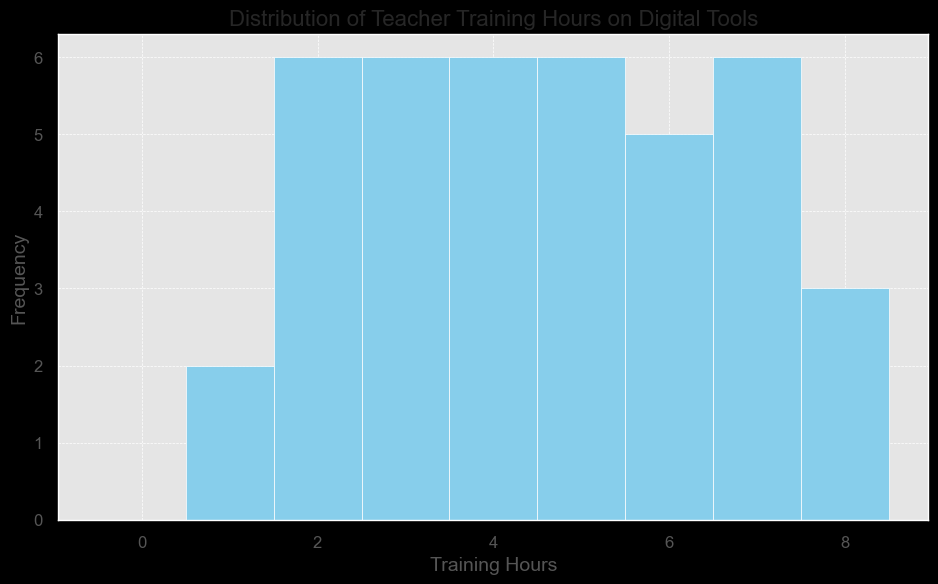What is the most common number of training hours among teachers? The most common number of training hours can be identified by the tallest bar on the histogram. In this case, the tallest bar corresponds to the training hours that occur most frequently.
Answer: 5 How many teachers received exactly 3 hours of training? The number of teachers who received exactly 3 hours of training can be determined by the height of the bar at 3 hours on the x-axis. Count the frequency indicated by this bar.
Answer: 6 What is the range of training hours observed in the data? The range is the difference between the maximum and minimum values of training hours. From the histogram, the lowest value is 1 and the highest is 8. Therefore, the range is 8 - 1.
Answer: 7 Which interval of training hours has the second highest frequency? To find the second highest frequency, look for the second tallest bar in the histogram. The interval it represents is the answer.
Answer: 4 How many teachers received more than 5 hours of training? Count the number of bars corresponding to training hours greater than 5 and sum their frequencies. Bars for 6, 7, and 8 hours need to be considered.
Answer: 15 How many teachers received less than or equal to 2 hours of training? Sum the frequencies of bars corresponding to training hours of 2 or less. This includes the bars for 1 and 2 hours.
Answer: 6 What is the median number of training hours? The median can be approximated by locating the middle value in a sorted list of training hours. With 39 teachers, the 20th value (middle value) will be the median. Refer to the histogram distribution to find which interval this falls into.
Answer: 5 How much is the frequency of teachers receiving 4 hours of training compared to those receiving 8 hours of training? Compare the heights of the bars for 4 hours and 8 hours. The bar for 4 hours is taller, indicating a higher frequency.
Answer: 8 VS 4 What is the total number of teachers trained? Sum the frequencies of all bars in the histogram to find the total number of teachers. This gives a complete count of all data points.
Answer: 38 What is the average number of training hours per teacher? To find the average, sum the products of each interval's frequency and their corresponding training hours, and divide by the total number of teachers. For example, (1*2 + 2*6 + 3*9 + 4*7 ... + 8*4)/38.
Answer: 5.13 